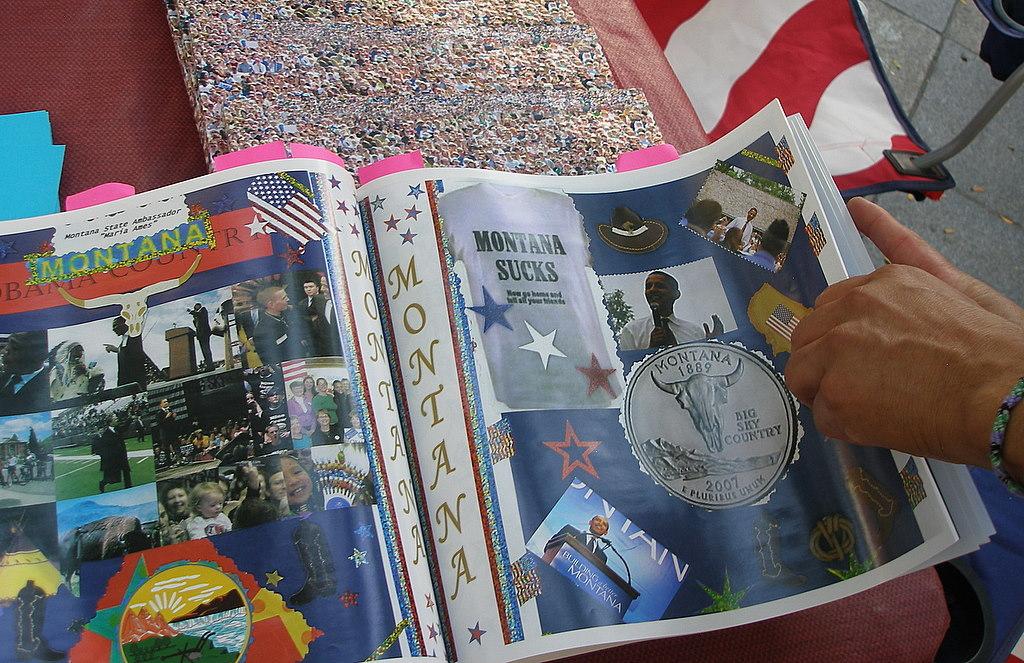What place sucks?
Make the answer very short. Montana. What is the year on the coin on the right page?
Your answer should be very brief. 2007. 